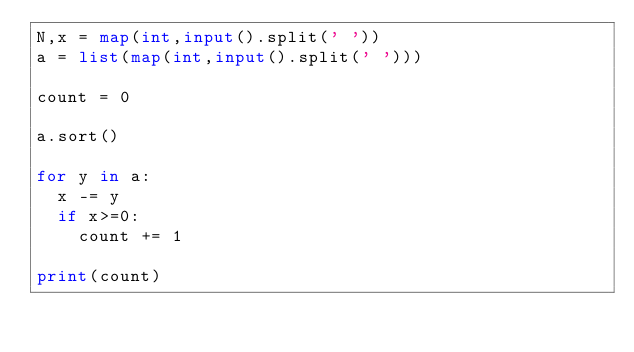Convert code to text. <code><loc_0><loc_0><loc_500><loc_500><_Python_>N,x = map(int,input().split(' '))
a = list(map(int,input().split(' ')))

count = 0

a.sort()

for y in a:
  x -= y
  if x>=0:
    count += 1
    
print(count)</code> 